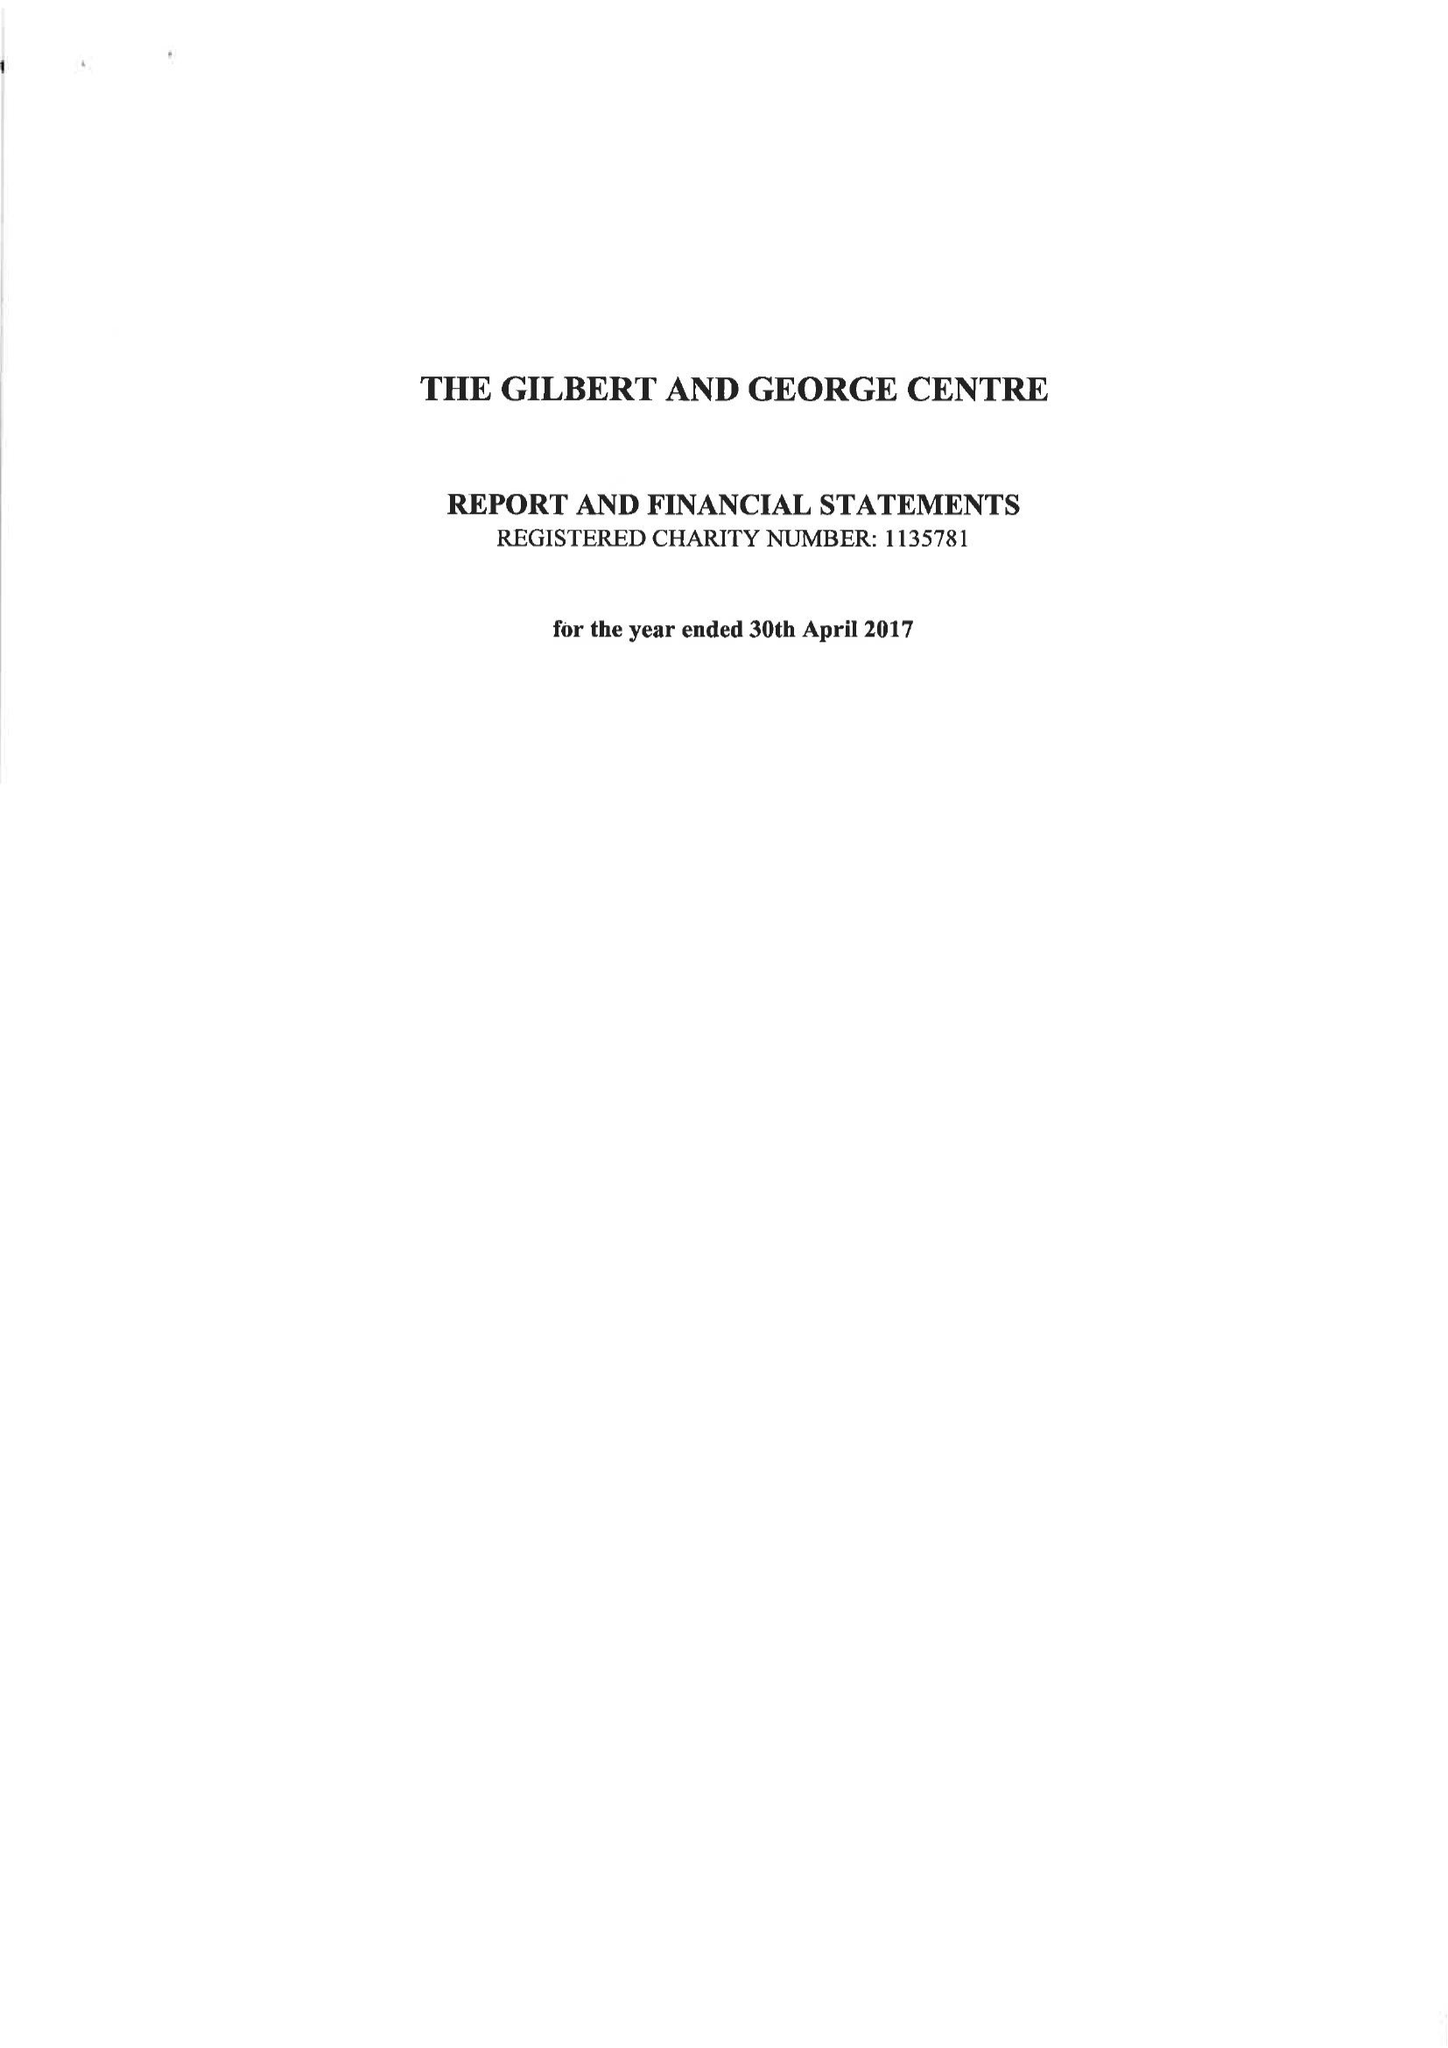What is the value for the income_annually_in_british_pounds?
Answer the question using a single word or phrase. 63206.00 